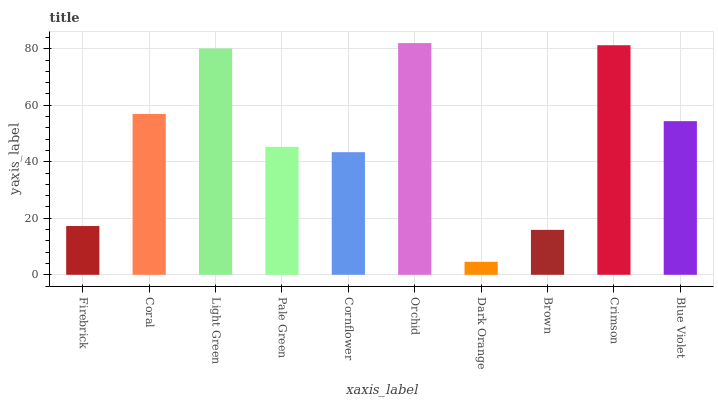Is Dark Orange the minimum?
Answer yes or no. Yes. Is Orchid the maximum?
Answer yes or no. Yes. Is Coral the minimum?
Answer yes or no. No. Is Coral the maximum?
Answer yes or no. No. Is Coral greater than Firebrick?
Answer yes or no. Yes. Is Firebrick less than Coral?
Answer yes or no. Yes. Is Firebrick greater than Coral?
Answer yes or no. No. Is Coral less than Firebrick?
Answer yes or no. No. Is Blue Violet the high median?
Answer yes or no. Yes. Is Pale Green the low median?
Answer yes or no. Yes. Is Pale Green the high median?
Answer yes or no. No. Is Brown the low median?
Answer yes or no. No. 